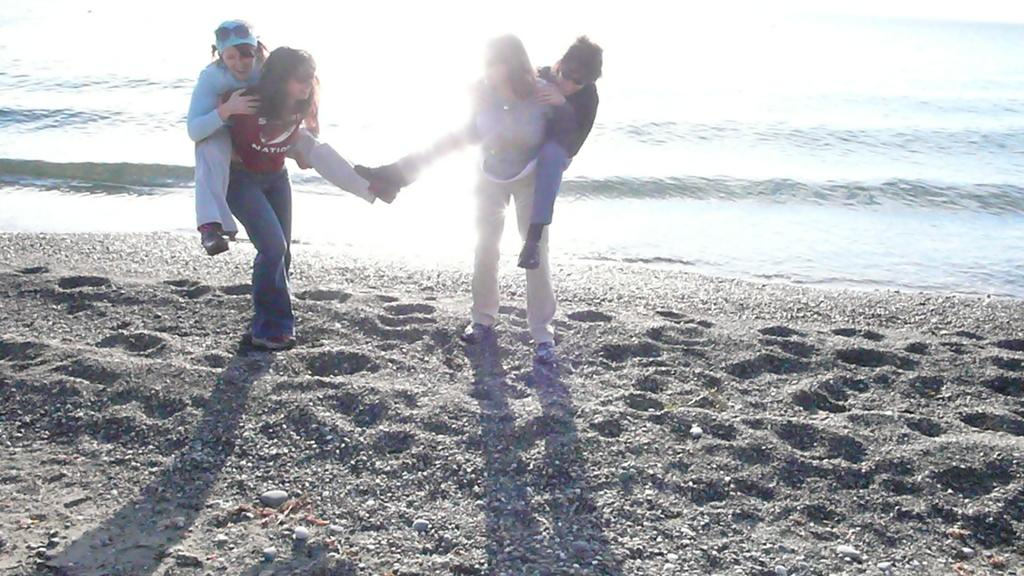Who or what can be seen in the image? There are people in the image. What type of environment is depicted in the image? The image shows a water and sandy environment, likely a beach. What other objects or features can be seen in the image? There are stones visible in the image. What type of quiver can be seen in the image? There is no quiver present in the image. How many lace patterns can be seen on the people's clothing in the image? There is no information about the people's clothing or lace patterns in the image. 